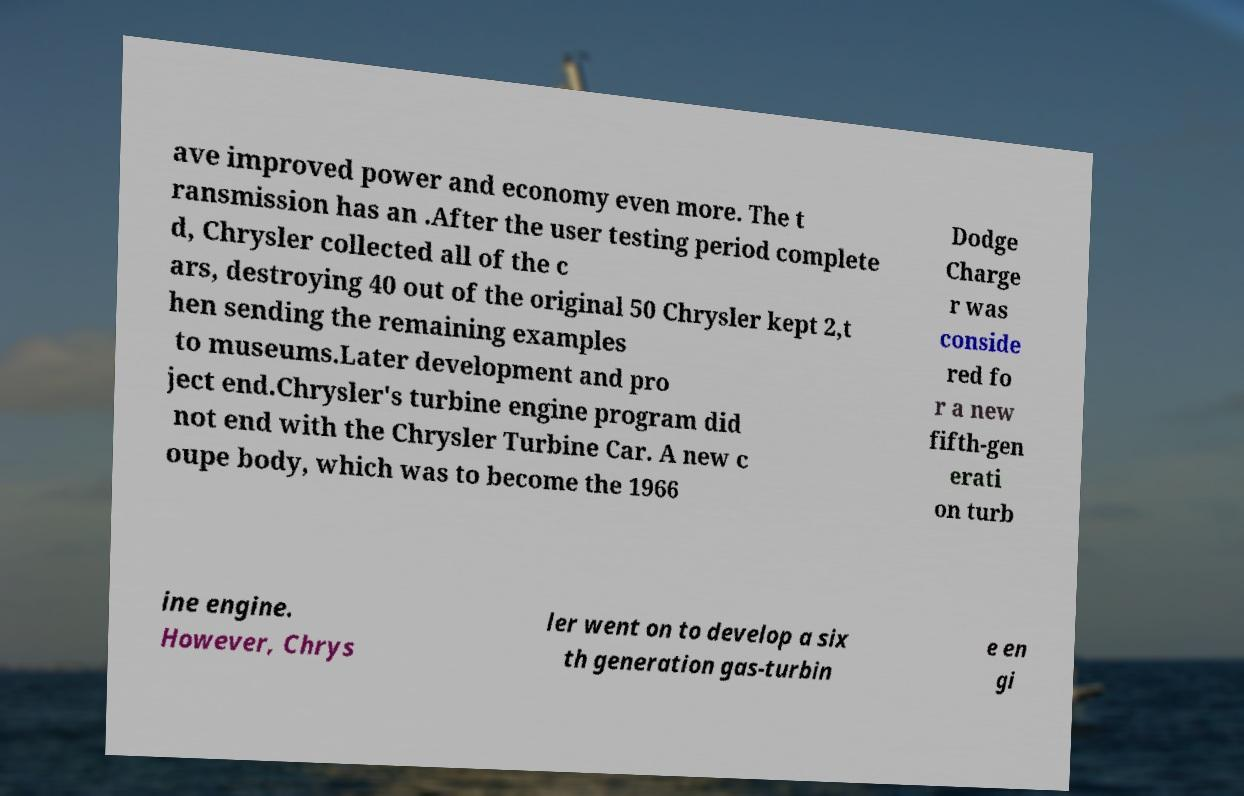What messages or text are displayed in this image? I need them in a readable, typed format. ave improved power and economy even more. The t ransmission has an .After the user testing period complete d, Chrysler collected all of the c ars, destroying 40 out of the original 50 Chrysler kept 2,t hen sending the remaining examples to museums.Later development and pro ject end.Chrysler's turbine engine program did not end with the Chrysler Turbine Car. A new c oupe body, which was to become the 1966 Dodge Charge r was conside red fo r a new fifth-gen erati on turb ine engine. However, Chrys ler went on to develop a six th generation gas-turbin e en gi 